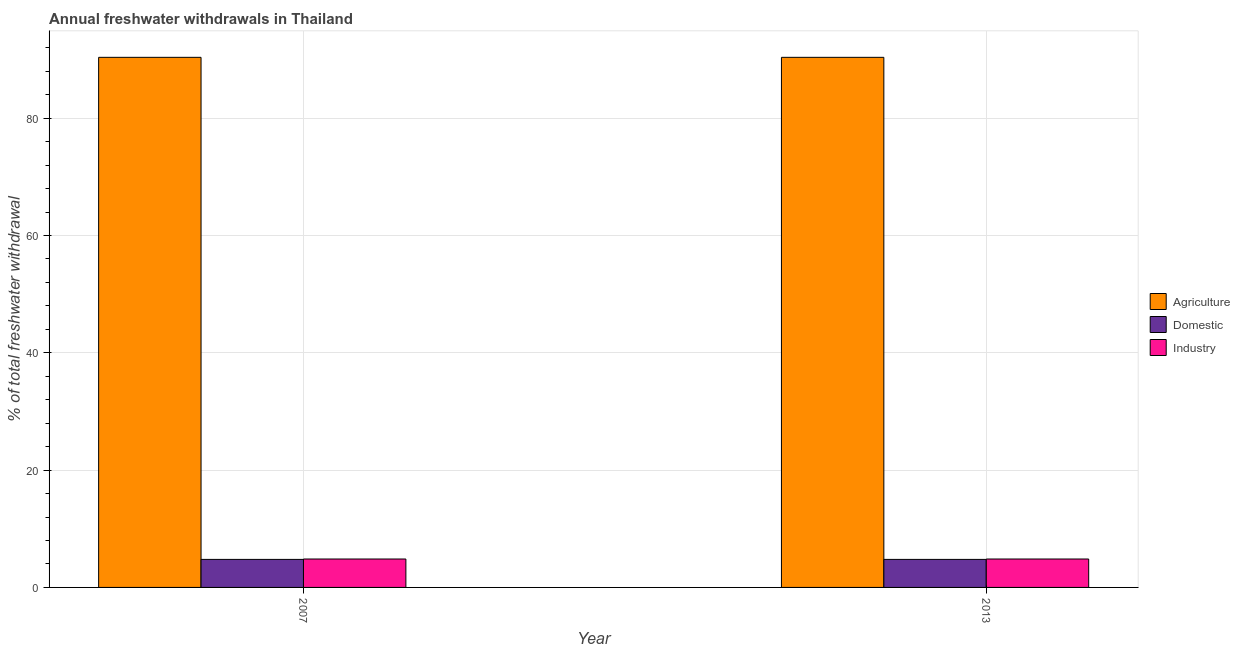How many groups of bars are there?
Your answer should be compact. 2. Are the number of bars per tick equal to the number of legend labels?
Keep it short and to the point. Yes. Are the number of bars on each tick of the X-axis equal?
Your response must be concise. Yes. How many bars are there on the 1st tick from the right?
Ensure brevity in your answer.  3. What is the label of the 1st group of bars from the left?
Your response must be concise. 2007. In how many cases, is the number of bars for a given year not equal to the number of legend labels?
Your response must be concise. 0. What is the percentage of freshwater withdrawal for domestic purposes in 2013?
Give a very brief answer. 4.78. Across all years, what is the maximum percentage of freshwater withdrawal for agriculture?
Keep it short and to the point. 90.37. Across all years, what is the minimum percentage of freshwater withdrawal for domestic purposes?
Your answer should be very brief. 4.78. In which year was the percentage of freshwater withdrawal for domestic purposes maximum?
Make the answer very short. 2007. What is the total percentage of freshwater withdrawal for industry in the graph?
Provide a succinct answer. 9.69. What is the difference between the percentage of freshwater withdrawal for agriculture in 2007 and the percentage of freshwater withdrawal for domestic purposes in 2013?
Offer a very short reply. 0. What is the average percentage of freshwater withdrawal for domestic purposes per year?
Ensure brevity in your answer.  4.78. In how many years, is the percentage of freshwater withdrawal for agriculture greater than 20 %?
Offer a terse response. 2. What is the ratio of the percentage of freshwater withdrawal for agriculture in 2007 to that in 2013?
Your answer should be very brief. 1. In how many years, is the percentage of freshwater withdrawal for industry greater than the average percentage of freshwater withdrawal for industry taken over all years?
Provide a short and direct response. 0. What does the 1st bar from the left in 2013 represents?
Offer a terse response. Agriculture. What does the 1st bar from the right in 2013 represents?
Offer a very short reply. Industry. Is it the case that in every year, the sum of the percentage of freshwater withdrawal for agriculture and percentage of freshwater withdrawal for domestic purposes is greater than the percentage of freshwater withdrawal for industry?
Your answer should be very brief. Yes. How many bars are there?
Your answer should be compact. 6. What is the difference between two consecutive major ticks on the Y-axis?
Your answer should be very brief. 20. Are the values on the major ticks of Y-axis written in scientific E-notation?
Provide a short and direct response. No. Where does the legend appear in the graph?
Give a very brief answer. Center right. How many legend labels are there?
Keep it short and to the point. 3. How are the legend labels stacked?
Your response must be concise. Vertical. What is the title of the graph?
Give a very brief answer. Annual freshwater withdrawals in Thailand. Does "Ores and metals" appear as one of the legend labels in the graph?
Your answer should be very brief. No. What is the label or title of the X-axis?
Make the answer very short. Year. What is the label or title of the Y-axis?
Offer a very short reply. % of total freshwater withdrawal. What is the % of total freshwater withdrawal of Agriculture in 2007?
Your answer should be very brief. 90.37. What is the % of total freshwater withdrawal in Domestic in 2007?
Your response must be concise. 4.78. What is the % of total freshwater withdrawal of Industry in 2007?
Give a very brief answer. 4.85. What is the % of total freshwater withdrawal in Agriculture in 2013?
Keep it short and to the point. 90.37. What is the % of total freshwater withdrawal in Domestic in 2013?
Provide a short and direct response. 4.78. What is the % of total freshwater withdrawal in Industry in 2013?
Your answer should be compact. 4.85. Across all years, what is the maximum % of total freshwater withdrawal of Agriculture?
Offer a very short reply. 90.37. Across all years, what is the maximum % of total freshwater withdrawal of Domestic?
Keep it short and to the point. 4.78. Across all years, what is the maximum % of total freshwater withdrawal in Industry?
Provide a short and direct response. 4.85. Across all years, what is the minimum % of total freshwater withdrawal in Agriculture?
Keep it short and to the point. 90.37. Across all years, what is the minimum % of total freshwater withdrawal in Domestic?
Provide a succinct answer. 4.78. Across all years, what is the minimum % of total freshwater withdrawal of Industry?
Offer a terse response. 4.85. What is the total % of total freshwater withdrawal in Agriculture in the graph?
Provide a short and direct response. 180.74. What is the total % of total freshwater withdrawal in Domestic in the graph?
Offer a very short reply. 9.56. What is the total % of total freshwater withdrawal in Industry in the graph?
Keep it short and to the point. 9.69. What is the difference between the % of total freshwater withdrawal in Agriculture in 2007 and that in 2013?
Ensure brevity in your answer.  0. What is the difference between the % of total freshwater withdrawal of Domestic in 2007 and that in 2013?
Make the answer very short. 0. What is the difference between the % of total freshwater withdrawal in Industry in 2007 and that in 2013?
Your response must be concise. 0. What is the difference between the % of total freshwater withdrawal of Agriculture in 2007 and the % of total freshwater withdrawal of Domestic in 2013?
Ensure brevity in your answer.  85.59. What is the difference between the % of total freshwater withdrawal of Agriculture in 2007 and the % of total freshwater withdrawal of Industry in 2013?
Keep it short and to the point. 85.52. What is the difference between the % of total freshwater withdrawal of Domestic in 2007 and the % of total freshwater withdrawal of Industry in 2013?
Give a very brief answer. -0.07. What is the average % of total freshwater withdrawal in Agriculture per year?
Make the answer very short. 90.37. What is the average % of total freshwater withdrawal of Domestic per year?
Your response must be concise. 4.78. What is the average % of total freshwater withdrawal in Industry per year?
Give a very brief answer. 4.85. In the year 2007, what is the difference between the % of total freshwater withdrawal in Agriculture and % of total freshwater withdrawal in Domestic?
Your answer should be very brief. 85.59. In the year 2007, what is the difference between the % of total freshwater withdrawal of Agriculture and % of total freshwater withdrawal of Industry?
Provide a succinct answer. 85.52. In the year 2007, what is the difference between the % of total freshwater withdrawal of Domestic and % of total freshwater withdrawal of Industry?
Provide a short and direct response. -0.07. In the year 2013, what is the difference between the % of total freshwater withdrawal in Agriculture and % of total freshwater withdrawal in Domestic?
Provide a short and direct response. 85.59. In the year 2013, what is the difference between the % of total freshwater withdrawal in Agriculture and % of total freshwater withdrawal in Industry?
Make the answer very short. 85.52. In the year 2013, what is the difference between the % of total freshwater withdrawal of Domestic and % of total freshwater withdrawal of Industry?
Offer a terse response. -0.07. What is the ratio of the % of total freshwater withdrawal of Agriculture in 2007 to that in 2013?
Offer a very short reply. 1. What is the ratio of the % of total freshwater withdrawal in Domestic in 2007 to that in 2013?
Offer a terse response. 1. What is the ratio of the % of total freshwater withdrawal in Industry in 2007 to that in 2013?
Provide a short and direct response. 1. What is the difference between the highest and the second highest % of total freshwater withdrawal in Agriculture?
Offer a terse response. 0. What is the difference between the highest and the second highest % of total freshwater withdrawal in Domestic?
Give a very brief answer. 0. What is the difference between the highest and the second highest % of total freshwater withdrawal of Industry?
Your answer should be very brief. 0. 